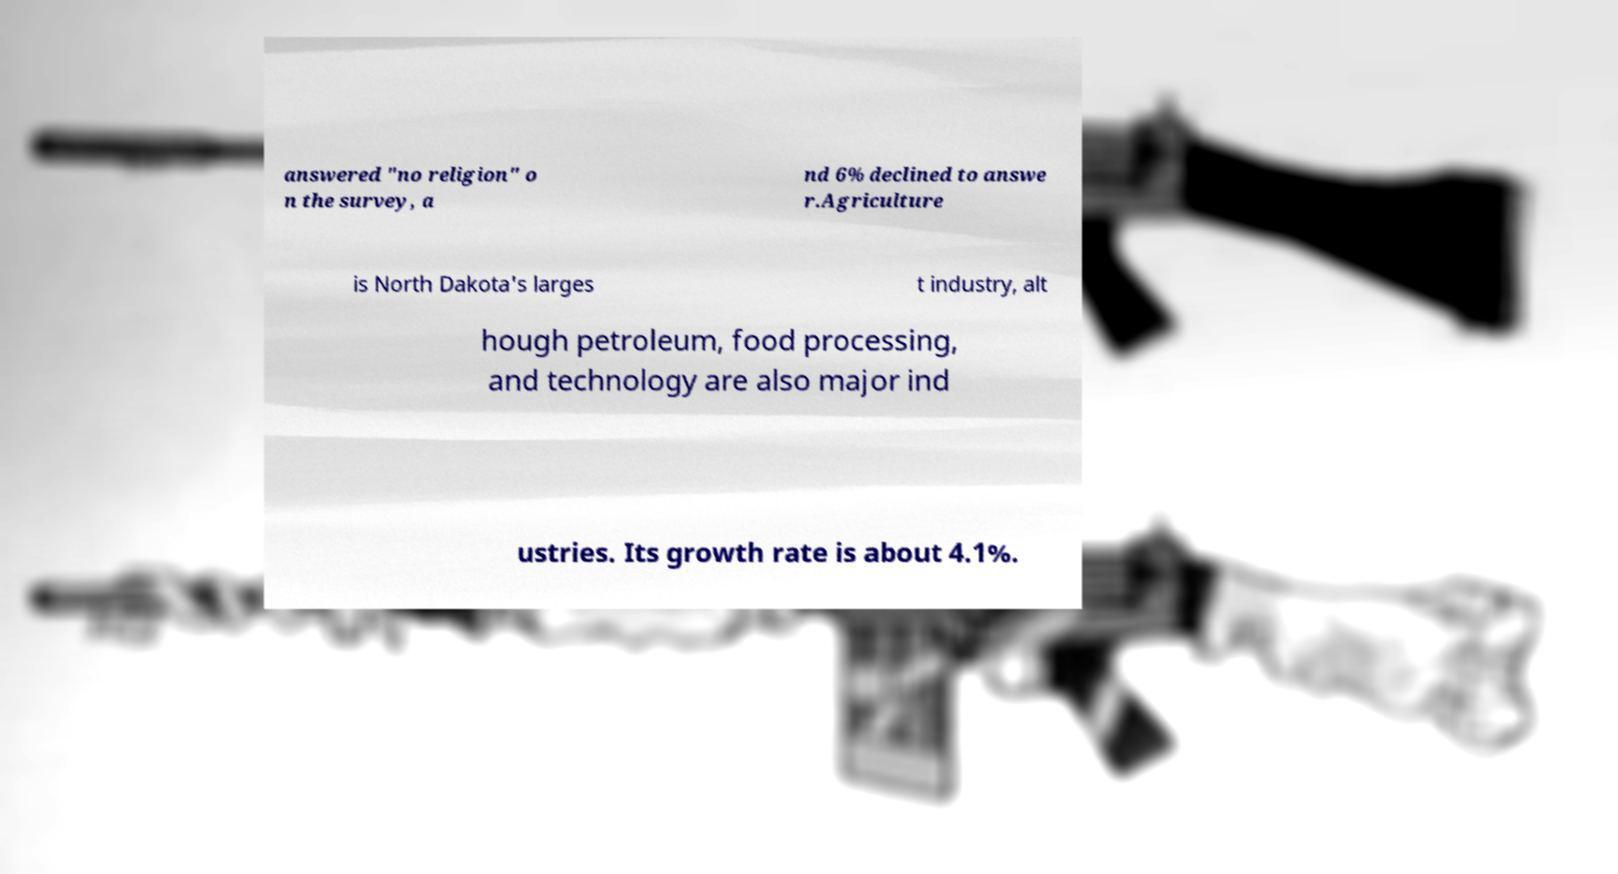I need the written content from this picture converted into text. Can you do that? answered "no religion" o n the survey, a nd 6% declined to answe r.Agriculture is North Dakota's larges t industry, alt hough petroleum, food processing, and technology are also major ind ustries. Its growth rate is about 4.1%. 